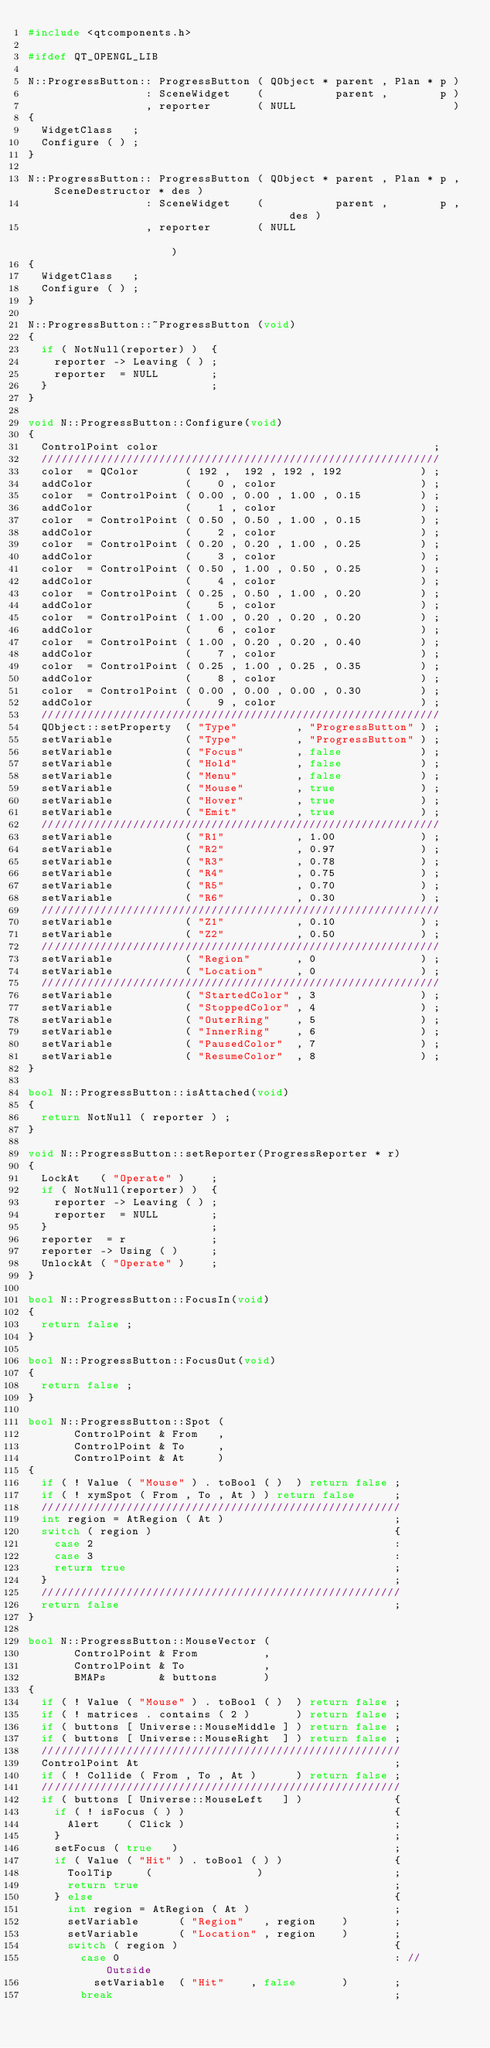<code> <loc_0><loc_0><loc_500><loc_500><_C++_>#include <qtcomponents.h>

#ifdef QT_OPENGL_LIB

N::ProgressButton:: ProgressButton ( QObject * parent , Plan * p )
                  : SceneWidget    (           parent ,        p )
                  , reporter       ( NULL                        )
{
  WidgetClass   ;
  Configure ( ) ;
}

N::ProgressButton:: ProgressButton ( QObject * parent , Plan * p , SceneDestructor * des )
                  : SceneWidget    (           parent ,        p ,                   des )
                  , reporter       ( NULL                                                )
{
  WidgetClass   ;
  Configure ( ) ;
}

N::ProgressButton::~ProgressButton (void)
{
  if ( NotNull(reporter) )  {
    reporter -> Leaving ( ) ;
    reporter  = NULL        ;
  }                         ;
}

void N::ProgressButton::Configure(void)
{
  ControlPoint color                                          ;
  /////////////////////////////////////////////////////////////
  color  = QColor       ( 192 ,  192 , 192 , 192            ) ;
  addColor              (    0 , color                      ) ;
  color  = ControlPoint ( 0.00 , 0.00 , 1.00 , 0.15         ) ;
  addColor              (    1 , color                      ) ;
  color  = ControlPoint ( 0.50 , 0.50 , 1.00 , 0.15         ) ;
  addColor              (    2 , color                      ) ;
  color  = ControlPoint ( 0.20 , 0.20 , 1.00 , 0.25         ) ;
  addColor              (    3 , color                      ) ;
  color  = ControlPoint ( 0.50 , 1.00 , 0.50 , 0.25         ) ;
  addColor              (    4 , color                      ) ;
  color  = ControlPoint ( 0.25 , 0.50 , 1.00 , 0.20         ) ;
  addColor              (    5 , color                      ) ;
  color  = ControlPoint ( 1.00 , 0.20 , 0.20 , 0.20         ) ;
  addColor              (    6 , color                      ) ;
  color  = ControlPoint ( 1.00 , 0.20 , 0.20 , 0.40         ) ;
  addColor              (    7 , color                      ) ;
  color  = ControlPoint ( 0.25 , 1.00 , 0.25 , 0.35         ) ;
  addColor              (    8 , color                      ) ;
  color  = ControlPoint ( 0.00 , 0.00 , 0.00 , 0.30         ) ;
  addColor              (    9 , color                      ) ;
  /////////////////////////////////////////////////////////////
  QObject::setProperty  ( "Type"         , "ProgressButton" ) ;
  setVariable           ( "Type"         , "ProgressButton" ) ;
  setVariable           ( "Focus"        , false            ) ;
  setVariable           ( "Hold"         , false            ) ;
  setVariable           ( "Menu"         , false            ) ;
  setVariable           ( "Mouse"        , true             ) ;
  setVariable           ( "Hover"        , true             ) ;
  setVariable           ( "Emit"         , true             ) ;
  /////////////////////////////////////////////////////////////
  setVariable           ( "R1"           , 1.00             ) ;
  setVariable           ( "R2"           , 0.97             ) ;
  setVariable           ( "R3"           , 0.78             ) ;
  setVariable           ( "R4"           , 0.75             ) ;
  setVariable           ( "R5"           , 0.70             ) ;
  setVariable           ( "R6"           , 0.30             ) ;
  /////////////////////////////////////////////////////////////
  setVariable           ( "Z1"           , 0.10             ) ;
  setVariable           ( "Z2"           , 0.50             ) ;
  /////////////////////////////////////////////////////////////
  setVariable           ( "Region"       , 0                ) ;
  setVariable           ( "Location"     , 0                ) ;
  /////////////////////////////////////////////////////////////
  setVariable           ( "StartedColor" , 3                ) ;
  setVariable           ( "StoppedColor" , 4                ) ;
  setVariable           ( "OuterRing"    , 5                ) ;
  setVariable           ( "InnerRing"    , 6                ) ;
  setVariable           ( "PausedColor"  , 7                ) ;
  setVariable           ( "ResumeColor"  , 8                ) ;
}

bool N::ProgressButton::isAttached(void)
{
  return NotNull ( reporter ) ;
}

void N::ProgressButton::setReporter(ProgressReporter * r)
{
  LockAt   ( "Operate" )    ;
  if ( NotNull(reporter) )  {
    reporter -> Leaving ( ) ;
    reporter  = NULL        ;
  }                         ;
  reporter  = r             ;
  reporter -> Using ( )     ;
  UnlockAt ( "Operate" )    ;
}

bool N::ProgressButton::FocusIn(void)
{
  return false ;
}

bool N::ProgressButton::FocusOut(void)
{
  return false ;
}

bool N::ProgressButton::Spot (
       ControlPoint & From   ,
       ControlPoint & To     ,
       ControlPoint & At     )
{
  if ( ! Value ( "Mouse" ) . toBool ( )  ) return false ;
  if ( ! xymSpot ( From , To , At ) ) return false      ;
  ///////////////////////////////////////////////////////
  int region = AtRegion ( At )                          ;
  switch ( region )                                     {
    case 2                                              :
    case 3                                              :
    return true                                         ;
  }                                                     ;
  ///////////////////////////////////////////////////////
  return false                                          ;
}

bool N::ProgressButton::MouseVector (
       ControlPoint & From          ,
       ControlPoint & To            ,
       BMAPs        & buttons       )
{
  if ( ! Value ( "Mouse" ) . toBool ( )  ) return false ;
  if ( ! matrices . contains ( 2 )       ) return false ;
  if ( buttons [ Universe::MouseMiddle ] ) return false ;
  if ( buttons [ Universe::MouseRight  ] ) return false ;
  ///////////////////////////////////////////////////////
  ControlPoint At                                       ;
  if ( ! Collide ( From , To , At )      ) return false ;
  ///////////////////////////////////////////////////////
  if ( buttons [ Universe::MouseLeft   ] )              {
    if ( ! isFocus ( ) )                                {
      Alert    ( Click )                                ;
    }                                                   ;
    setFocus ( true   )                                 ;
    if ( Value ( "Hit" ) . toBool ( ) )                 {
      ToolTip     (                )                    ;
      return true                                       ;
    } else                                              {
      int region = AtRegion ( At )                      ;
      setVariable      ( "Region"   , region    )       ;
      setVariable      ( "Location" , region    )       ;
      switch ( region )                                 {
        case 0                                          : // Outside
          setVariable  ( "Hit"    , false       )       ;
        break                                           ;</code> 